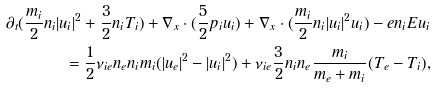Convert formula to latex. <formula><loc_0><loc_0><loc_500><loc_500>\partial _ { t } ( \frac { m _ { i } } { 2 } n _ { i } | u _ { i } | ^ { 2 } + \frac { 3 } { 2 } n _ { i } T _ { i } ) + \nabla _ { x } \cdot ( \frac { 5 } { 2 } p _ { i } u _ { i } ) + \nabla _ { x } \cdot ( \frac { m _ { i } } { 2 } n _ { i } | u _ { i } | ^ { 2 } u _ { i } ) - e n _ { i } E u _ { i } \\ = \frac { 1 } { 2 } \nu _ { i e } n _ { e } n _ { i } m _ { i } ( | u _ { e } | ^ { 2 } - | u _ { i } | ^ { 2 } ) + \nu _ { i e } \frac { 3 } { 2 } n _ { i } n _ { e } \frac { m _ { i } } { m _ { e } + m _ { i } } ( T _ { e } - T _ { i } ) ,</formula> 